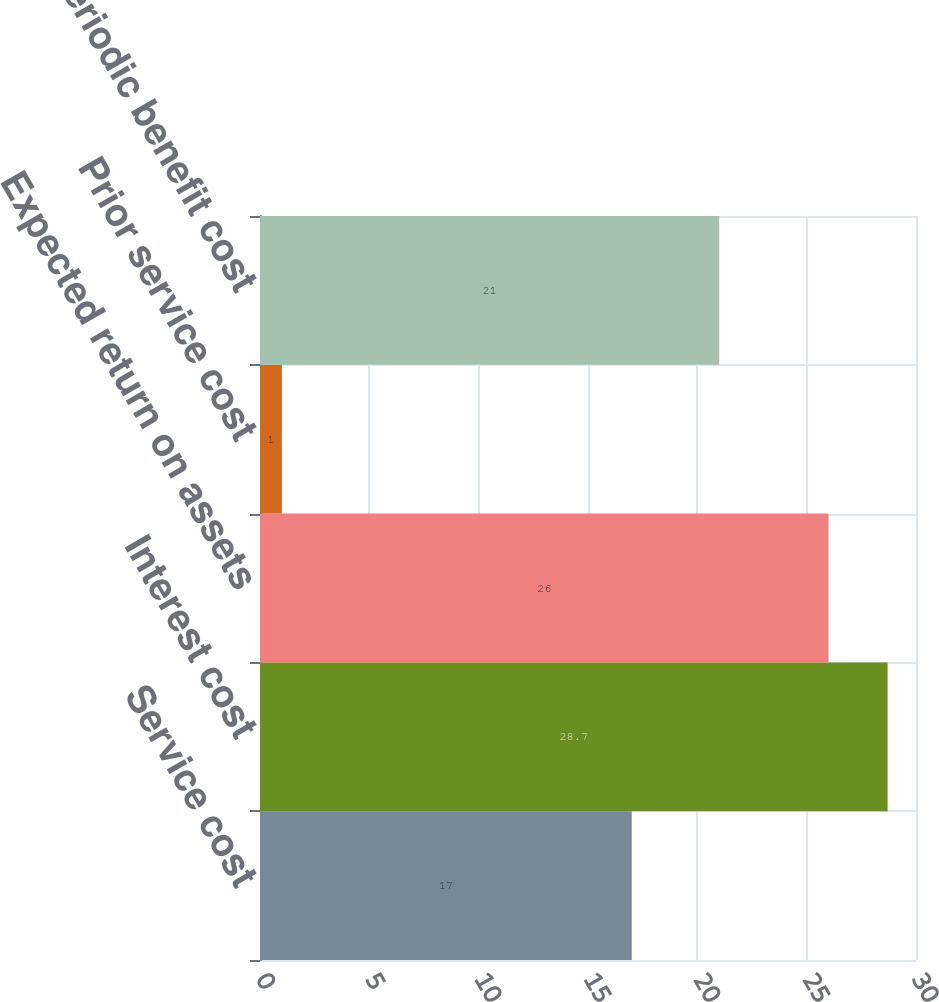Convert chart. <chart><loc_0><loc_0><loc_500><loc_500><bar_chart><fcel>Service cost<fcel>Interest cost<fcel>Expected return on assets<fcel>Prior service cost<fcel>Net periodic benefit cost<nl><fcel>17<fcel>28.7<fcel>26<fcel>1<fcel>21<nl></chart> 